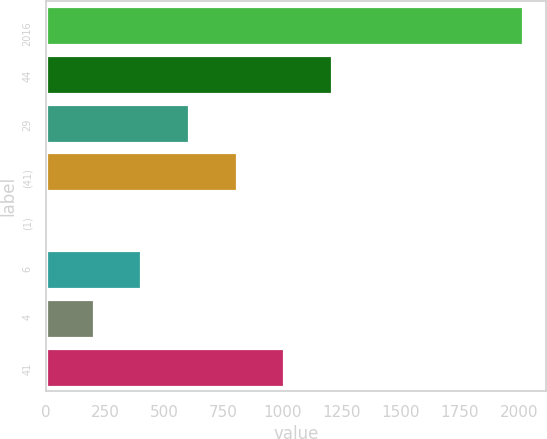Convert chart. <chart><loc_0><loc_0><loc_500><loc_500><bar_chart><fcel>2016<fcel>44<fcel>29<fcel>(41)<fcel>(1)<fcel>6<fcel>4<fcel>41<nl><fcel>2015<fcel>1209.4<fcel>605.2<fcel>806.6<fcel>1<fcel>403.8<fcel>202.4<fcel>1008<nl></chart> 